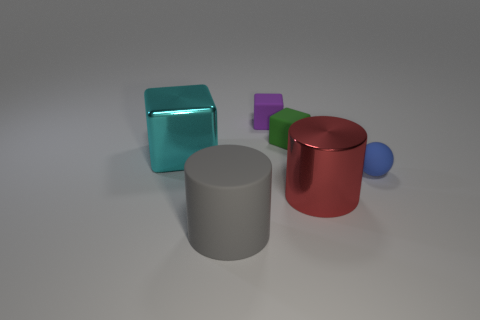There is a purple block that is the same size as the rubber ball; what material is it?
Provide a succinct answer. Rubber. What number of green objects are the same shape as the cyan object?
Your response must be concise. 1. What material is the cube that is both in front of the purple object and right of the large rubber cylinder?
Ensure brevity in your answer.  Rubber. Does the big gray thing have the same material as the large cube?
Provide a succinct answer. No. What number of other things are the same color as the large matte cylinder?
Offer a very short reply. 0. How many green objects are small things or tiny metallic objects?
Provide a short and direct response. 1. How big is the cyan metallic cube?
Offer a very short reply. Large. How many metal things are either red objects or big cyan cubes?
Keep it short and to the point. 2. Is the number of tiny blue balls less than the number of small green shiny balls?
Keep it short and to the point. No. How many other objects are there of the same material as the cyan object?
Make the answer very short. 1. 